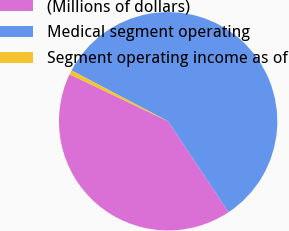Convert chart to OTSL. <chart><loc_0><loc_0><loc_500><loc_500><pie_chart><fcel>(Millions of dollars)<fcel>Medical segment operating<fcel>Segment operating income as of<nl><fcel>41.42%<fcel>57.94%<fcel>0.64%<nl></chart> 